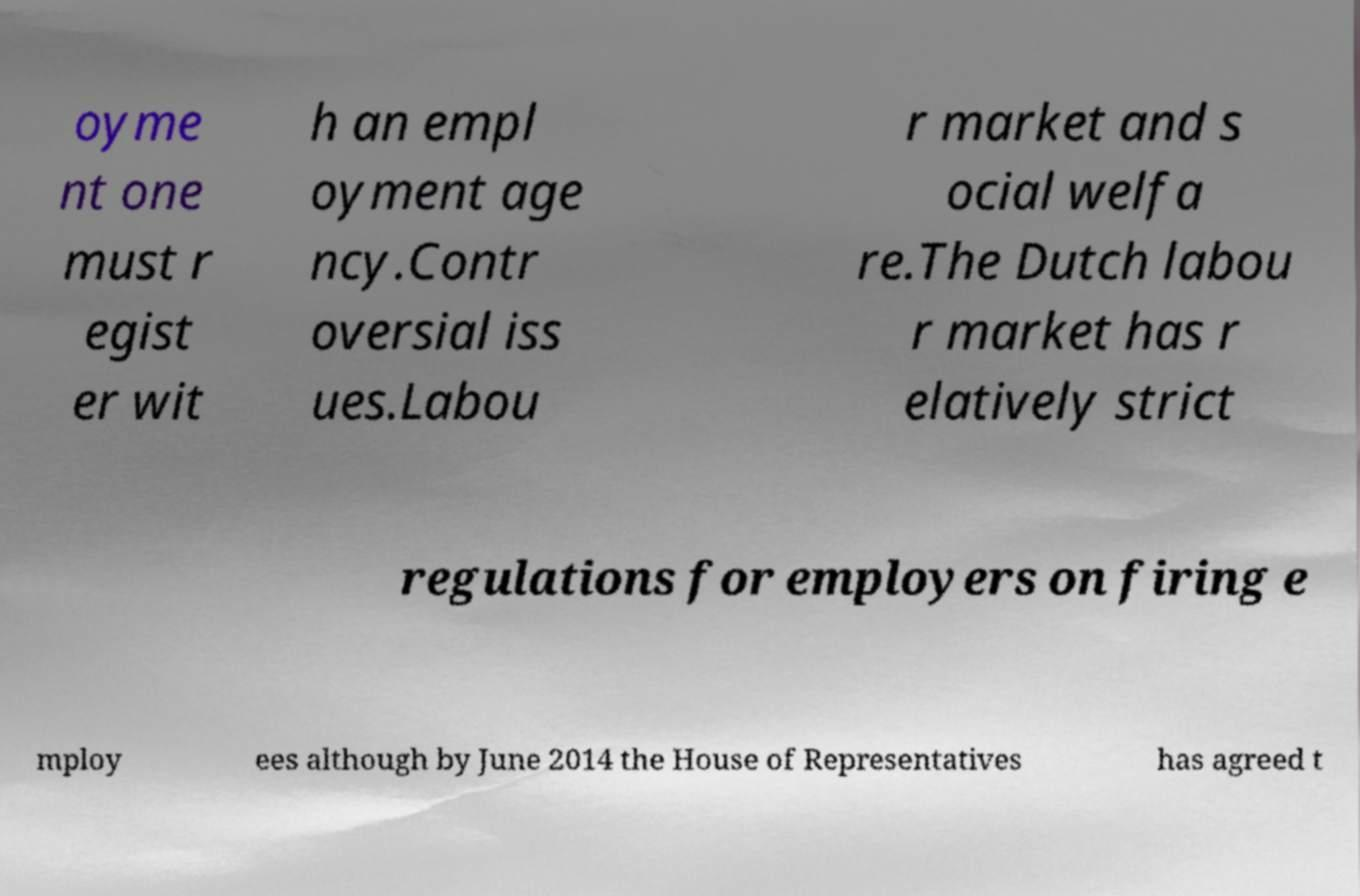I need the written content from this picture converted into text. Can you do that? oyme nt one must r egist er wit h an empl oyment age ncy.Contr oversial iss ues.Labou r market and s ocial welfa re.The Dutch labou r market has r elatively strict regulations for employers on firing e mploy ees although by June 2014 the House of Representatives has agreed t 